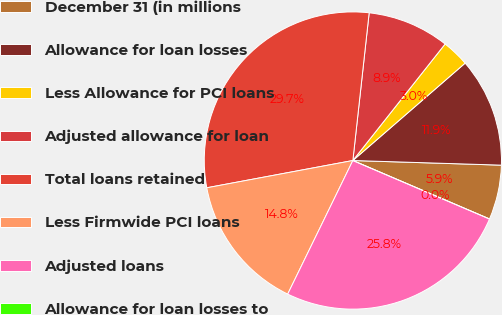Convert chart to OTSL. <chart><loc_0><loc_0><loc_500><loc_500><pie_chart><fcel>December 31 (in millions<fcel>Allowance for loan losses<fcel>Less Allowance for PCI loans<fcel>Adjusted allowance for loan<fcel>Total loans retained<fcel>Less Firmwide PCI loans<fcel>Adjusted loans<fcel>Allowance for loan losses to<nl><fcel>5.94%<fcel>11.87%<fcel>2.97%<fcel>8.91%<fcel>29.69%<fcel>14.84%<fcel>25.79%<fcel>0.0%<nl></chart> 